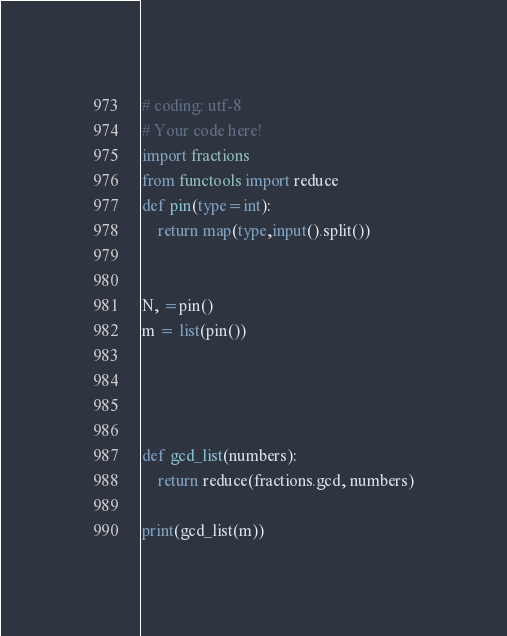Convert code to text. <code><loc_0><loc_0><loc_500><loc_500><_Python_># coding: utf-8
# Your code here!
import fractions
from functools import reduce
def pin(type=int):
    return map(type,input().split())


N, =pin()
m = list(pin())




def gcd_list(numbers):
    return reduce(fractions.gcd, numbers)

print(gcd_list(m))</code> 